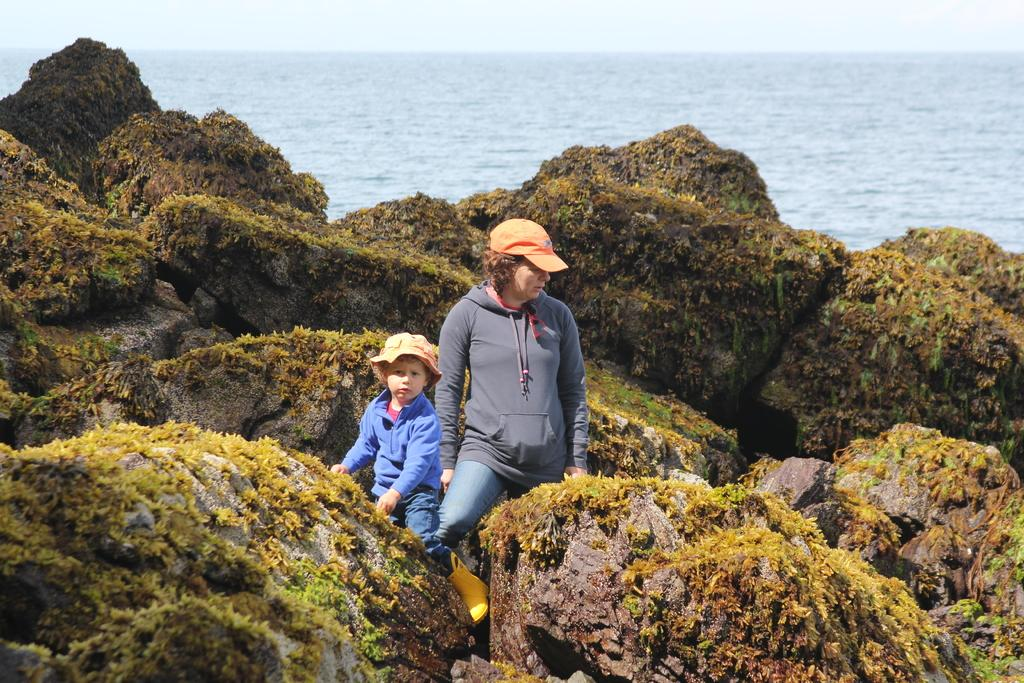What can be seen in the foreground of the image? There are rocks and grass in the foreground of the image. Are there any people in the image? Yes, there are people in the foreground of the image. What is visible in the background of the image? There is water visible in the background of the image. What is visible at the top of the image? The sky is visible at the top of the image. What type of insect can be seen sorting items in the room in the image? There is no insect or room present in the image; it features rocks, grass, people, water, and the sky. 